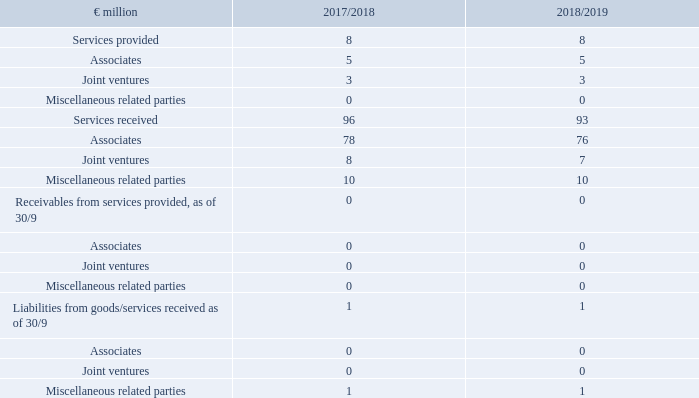49. Notes on related parties
In financial year 2018/19, METRO maintained the following business relations to related companies:
Transactions with associated companies and other related parties
The services received totalling €93 million (2017/18: €96 million) that METRO companies received from associates and other related parties in financial year 2018/19 consisted mainly of real estate leases in the amount of €79 million (2017/18: €80 million), thereof €76 million from associates; (2017/18: €78 million) and the rendering of services in the amount of €15 million (2017/18: €16 million), thereof €7 million from joint ventures; (2017/18: €8 million). Other future financial commitments in the amount of €667 million (2017/18: €719 million) consist of tenancy agreements with the following associated companies: OPCI FWP France, OPCI FWS France, Habib METRO Pakistan and the Mayfair group. In financial year 2018/19, METRO companies provided services to companies belonging to the group of associates and related parties in the amount of €8 million (2017/18: €8 million). A dividend of €38 million has been paid out to a shareholder with significant influence. Business relations with related parties are based on contractual agreements providing for arm’s length prices. As in financial year 2017/18, there were no business relations with related natural persons and companies of management in key positions in financial year 2018/19.
Related persons (compensation for management in key positions)
The management in key positions consists of members of the Management Board and the Supervisory Board of METRO AG. Thus, the expenses for members of the Management Board of METRO AG amounted to €6.9 million (2017/18: €5.2 million) for short-term benefits and €3.7 million (2017/18: €7.0 million) for post-employment benefits. Thereof an amount of €3.0 million relates to termination benefits paid in financial year 2018/19. The expenses for existing compensation programmes with long-term incentive effect in financial year 2018/19, calculated in accordance with IFRS 2, amounted to €2.6 million (2017/18: €0.7 million). The short-term compensation for the members of the Supervisory Board of METRO AG amounted to €2.2 million (2017/18: €2.2 million). The total compensation for members of the Management Board in key positions in financial year 2018/19 amounted to €15.4 million (2017/18: €15.1 million).
What was the amount of services provided in FY2019?
Answer scale should be: million. 8. Who were the parties to which METRO maintained business relations with related companies? Associates, joint ventures, miscellaneous related parties. What were the business relations to related companies listed in the table? Services provided, services received, receivables from services provided, as of 30/9, liabilities from goods/services received as of 30/9. In which year were services received larger? 96>93
Answer: 2018. What was the change in services received in FY2019 from FY2018?
Answer scale should be: million. 93-96
Answer: -3. What was the percentage change in services received in FY2019 from FY2018?
Answer scale should be: percent. (93-96)/96
Answer: -3.12. 